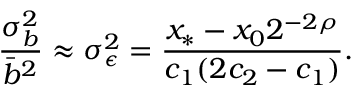<formula> <loc_0><loc_0><loc_500><loc_500>\frac { \sigma _ { b } ^ { 2 } } { \bar { b } ^ { 2 } } \approx \sigma _ { \epsilon } ^ { 2 } = \frac { x _ { * } - x _ { 0 } 2 ^ { - 2 \rho } } { c _ { 1 } ( 2 c _ { 2 } - c _ { 1 } ) } .</formula> 